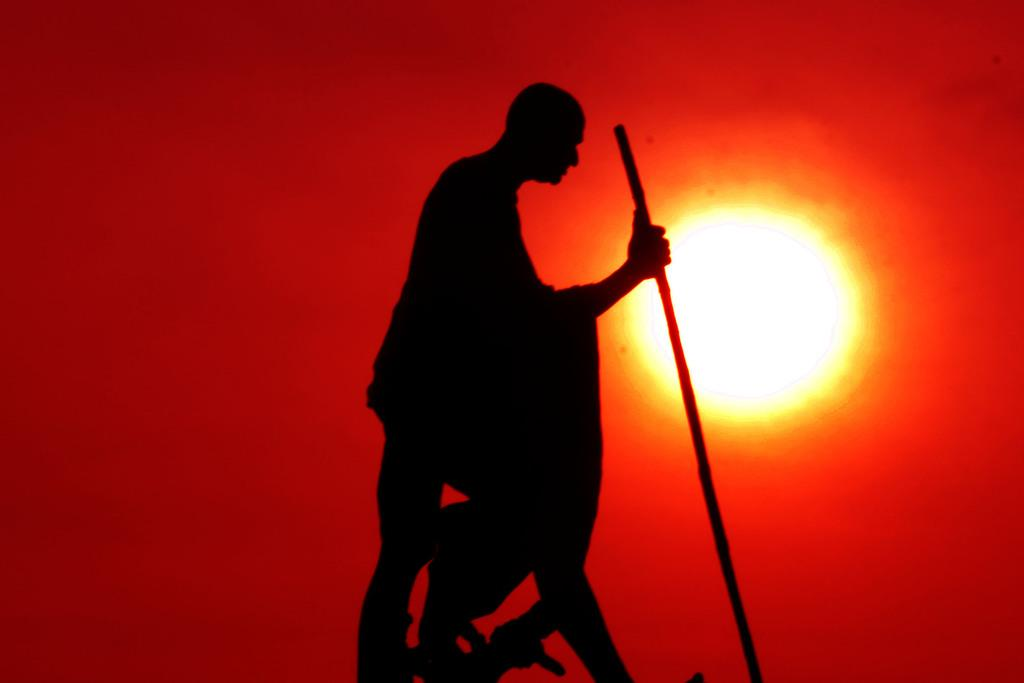What is the main subject of the image? There is a person in the image. What is the person holding in the image? The person is holding a stick. What can be seen in the background of the image? There is sky visible in the background of the image. Can the sun be seen in the image? Yes, the sun is observable in the sky. What type of eggs can be seen in the image? There are no eggs present in the image. Can you tell me how many cherries are on the stick held by the person in the image? There is no mention of cherries in the image; the person is holding a stick. 